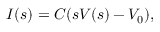<formula> <loc_0><loc_0><loc_500><loc_500>I ( s ) = C ( s V ( s ) - V _ { 0 } ) ,</formula> 